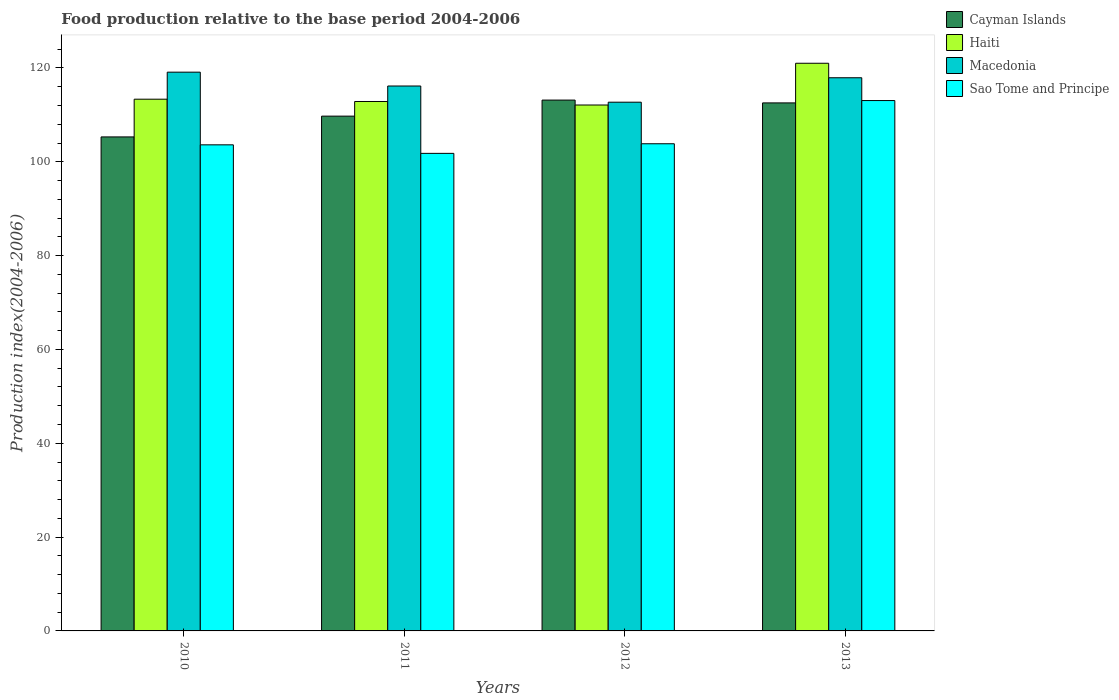How many groups of bars are there?
Make the answer very short. 4. What is the label of the 4th group of bars from the left?
Provide a succinct answer. 2013. In how many cases, is the number of bars for a given year not equal to the number of legend labels?
Give a very brief answer. 0. What is the food production index in Macedonia in 2011?
Offer a terse response. 116.16. Across all years, what is the maximum food production index in Sao Tome and Principe?
Offer a terse response. 113.06. Across all years, what is the minimum food production index in Macedonia?
Give a very brief answer. 112.71. In which year was the food production index in Cayman Islands maximum?
Offer a terse response. 2012. What is the total food production index in Macedonia in the graph?
Offer a terse response. 465.9. What is the difference between the food production index in Haiti in 2010 and that in 2013?
Make the answer very short. -7.66. What is the difference between the food production index in Sao Tome and Principe in 2011 and the food production index in Haiti in 2012?
Offer a terse response. -10.31. What is the average food production index in Haiti per year?
Provide a short and direct response. 114.83. In the year 2011, what is the difference between the food production index in Macedonia and food production index in Cayman Islands?
Provide a succinct answer. 6.42. In how many years, is the food production index in Cayman Islands greater than 92?
Your answer should be compact. 4. What is the ratio of the food production index in Haiti in 2010 to that in 2011?
Keep it short and to the point. 1. Is the food production index in Sao Tome and Principe in 2010 less than that in 2012?
Keep it short and to the point. Yes. What is the difference between the highest and the second highest food production index in Macedonia?
Your answer should be very brief. 1.19. What is the difference between the highest and the lowest food production index in Sao Tome and Principe?
Make the answer very short. 11.26. Is it the case that in every year, the sum of the food production index in Macedonia and food production index in Haiti is greater than the sum of food production index in Sao Tome and Principe and food production index in Cayman Islands?
Make the answer very short. Yes. What does the 1st bar from the left in 2012 represents?
Provide a succinct answer. Cayman Islands. What does the 2nd bar from the right in 2013 represents?
Provide a short and direct response. Macedonia. Is it the case that in every year, the sum of the food production index in Haiti and food production index in Cayman Islands is greater than the food production index in Sao Tome and Principe?
Make the answer very short. Yes. Are all the bars in the graph horizontal?
Your answer should be compact. No. How many years are there in the graph?
Your answer should be compact. 4. What is the difference between two consecutive major ticks on the Y-axis?
Offer a terse response. 20. Does the graph contain any zero values?
Ensure brevity in your answer.  No. Does the graph contain grids?
Offer a very short reply. No. What is the title of the graph?
Ensure brevity in your answer.  Food production relative to the base period 2004-2006. What is the label or title of the Y-axis?
Your answer should be very brief. Production index(2004-2006). What is the Production index(2004-2006) of Cayman Islands in 2010?
Offer a very short reply. 105.31. What is the Production index(2004-2006) of Haiti in 2010?
Provide a succinct answer. 113.35. What is the Production index(2004-2006) of Macedonia in 2010?
Make the answer very short. 119.11. What is the Production index(2004-2006) of Sao Tome and Principe in 2010?
Ensure brevity in your answer.  103.62. What is the Production index(2004-2006) in Cayman Islands in 2011?
Offer a terse response. 109.74. What is the Production index(2004-2006) in Haiti in 2011?
Your answer should be compact. 112.86. What is the Production index(2004-2006) in Macedonia in 2011?
Keep it short and to the point. 116.16. What is the Production index(2004-2006) of Sao Tome and Principe in 2011?
Offer a very short reply. 101.8. What is the Production index(2004-2006) in Cayman Islands in 2012?
Keep it short and to the point. 113.16. What is the Production index(2004-2006) in Haiti in 2012?
Your answer should be very brief. 112.11. What is the Production index(2004-2006) in Macedonia in 2012?
Ensure brevity in your answer.  112.71. What is the Production index(2004-2006) of Sao Tome and Principe in 2012?
Give a very brief answer. 103.85. What is the Production index(2004-2006) of Cayman Islands in 2013?
Provide a short and direct response. 112.56. What is the Production index(2004-2006) of Haiti in 2013?
Keep it short and to the point. 121.01. What is the Production index(2004-2006) in Macedonia in 2013?
Give a very brief answer. 117.92. What is the Production index(2004-2006) of Sao Tome and Principe in 2013?
Ensure brevity in your answer.  113.06. Across all years, what is the maximum Production index(2004-2006) in Cayman Islands?
Offer a very short reply. 113.16. Across all years, what is the maximum Production index(2004-2006) in Haiti?
Your answer should be compact. 121.01. Across all years, what is the maximum Production index(2004-2006) of Macedonia?
Your response must be concise. 119.11. Across all years, what is the maximum Production index(2004-2006) of Sao Tome and Principe?
Your response must be concise. 113.06. Across all years, what is the minimum Production index(2004-2006) in Cayman Islands?
Your answer should be very brief. 105.31. Across all years, what is the minimum Production index(2004-2006) of Haiti?
Give a very brief answer. 112.11. Across all years, what is the minimum Production index(2004-2006) in Macedonia?
Your answer should be very brief. 112.71. Across all years, what is the minimum Production index(2004-2006) of Sao Tome and Principe?
Your answer should be very brief. 101.8. What is the total Production index(2004-2006) in Cayman Islands in the graph?
Keep it short and to the point. 440.77. What is the total Production index(2004-2006) of Haiti in the graph?
Offer a terse response. 459.33. What is the total Production index(2004-2006) of Macedonia in the graph?
Offer a terse response. 465.9. What is the total Production index(2004-2006) in Sao Tome and Principe in the graph?
Offer a terse response. 422.33. What is the difference between the Production index(2004-2006) in Cayman Islands in 2010 and that in 2011?
Give a very brief answer. -4.43. What is the difference between the Production index(2004-2006) of Haiti in 2010 and that in 2011?
Your answer should be very brief. 0.49. What is the difference between the Production index(2004-2006) in Macedonia in 2010 and that in 2011?
Offer a very short reply. 2.95. What is the difference between the Production index(2004-2006) of Sao Tome and Principe in 2010 and that in 2011?
Give a very brief answer. 1.82. What is the difference between the Production index(2004-2006) in Cayman Islands in 2010 and that in 2012?
Offer a terse response. -7.85. What is the difference between the Production index(2004-2006) in Haiti in 2010 and that in 2012?
Make the answer very short. 1.24. What is the difference between the Production index(2004-2006) of Macedonia in 2010 and that in 2012?
Give a very brief answer. 6.4. What is the difference between the Production index(2004-2006) in Sao Tome and Principe in 2010 and that in 2012?
Provide a succinct answer. -0.23. What is the difference between the Production index(2004-2006) in Cayman Islands in 2010 and that in 2013?
Provide a short and direct response. -7.25. What is the difference between the Production index(2004-2006) of Haiti in 2010 and that in 2013?
Ensure brevity in your answer.  -7.66. What is the difference between the Production index(2004-2006) in Macedonia in 2010 and that in 2013?
Make the answer very short. 1.19. What is the difference between the Production index(2004-2006) of Sao Tome and Principe in 2010 and that in 2013?
Offer a terse response. -9.44. What is the difference between the Production index(2004-2006) of Cayman Islands in 2011 and that in 2012?
Offer a terse response. -3.42. What is the difference between the Production index(2004-2006) in Haiti in 2011 and that in 2012?
Provide a short and direct response. 0.75. What is the difference between the Production index(2004-2006) in Macedonia in 2011 and that in 2012?
Your answer should be very brief. 3.45. What is the difference between the Production index(2004-2006) of Sao Tome and Principe in 2011 and that in 2012?
Your response must be concise. -2.05. What is the difference between the Production index(2004-2006) of Cayman Islands in 2011 and that in 2013?
Your answer should be very brief. -2.82. What is the difference between the Production index(2004-2006) of Haiti in 2011 and that in 2013?
Offer a very short reply. -8.15. What is the difference between the Production index(2004-2006) of Macedonia in 2011 and that in 2013?
Your response must be concise. -1.76. What is the difference between the Production index(2004-2006) of Sao Tome and Principe in 2011 and that in 2013?
Make the answer very short. -11.26. What is the difference between the Production index(2004-2006) in Cayman Islands in 2012 and that in 2013?
Your answer should be very brief. 0.6. What is the difference between the Production index(2004-2006) of Macedonia in 2012 and that in 2013?
Keep it short and to the point. -5.21. What is the difference between the Production index(2004-2006) of Sao Tome and Principe in 2012 and that in 2013?
Provide a succinct answer. -9.21. What is the difference between the Production index(2004-2006) in Cayman Islands in 2010 and the Production index(2004-2006) in Haiti in 2011?
Your answer should be very brief. -7.55. What is the difference between the Production index(2004-2006) in Cayman Islands in 2010 and the Production index(2004-2006) in Macedonia in 2011?
Keep it short and to the point. -10.85. What is the difference between the Production index(2004-2006) of Cayman Islands in 2010 and the Production index(2004-2006) of Sao Tome and Principe in 2011?
Provide a short and direct response. 3.51. What is the difference between the Production index(2004-2006) of Haiti in 2010 and the Production index(2004-2006) of Macedonia in 2011?
Keep it short and to the point. -2.81. What is the difference between the Production index(2004-2006) in Haiti in 2010 and the Production index(2004-2006) in Sao Tome and Principe in 2011?
Your answer should be compact. 11.55. What is the difference between the Production index(2004-2006) in Macedonia in 2010 and the Production index(2004-2006) in Sao Tome and Principe in 2011?
Offer a very short reply. 17.31. What is the difference between the Production index(2004-2006) of Cayman Islands in 2010 and the Production index(2004-2006) of Haiti in 2012?
Your response must be concise. -6.8. What is the difference between the Production index(2004-2006) in Cayman Islands in 2010 and the Production index(2004-2006) in Macedonia in 2012?
Offer a terse response. -7.4. What is the difference between the Production index(2004-2006) of Cayman Islands in 2010 and the Production index(2004-2006) of Sao Tome and Principe in 2012?
Make the answer very short. 1.46. What is the difference between the Production index(2004-2006) in Haiti in 2010 and the Production index(2004-2006) in Macedonia in 2012?
Give a very brief answer. 0.64. What is the difference between the Production index(2004-2006) of Macedonia in 2010 and the Production index(2004-2006) of Sao Tome and Principe in 2012?
Ensure brevity in your answer.  15.26. What is the difference between the Production index(2004-2006) in Cayman Islands in 2010 and the Production index(2004-2006) in Haiti in 2013?
Keep it short and to the point. -15.7. What is the difference between the Production index(2004-2006) of Cayman Islands in 2010 and the Production index(2004-2006) of Macedonia in 2013?
Provide a succinct answer. -12.61. What is the difference between the Production index(2004-2006) of Cayman Islands in 2010 and the Production index(2004-2006) of Sao Tome and Principe in 2013?
Provide a succinct answer. -7.75. What is the difference between the Production index(2004-2006) in Haiti in 2010 and the Production index(2004-2006) in Macedonia in 2013?
Your response must be concise. -4.57. What is the difference between the Production index(2004-2006) in Haiti in 2010 and the Production index(2004-2006) in Sao Tome and Principe in 2013?
Offer a terse response. 0.29. What is the difference between the Production index(2004-2006) in Macedonia in 2010 and the Production index(2004-2006) in Sao Tome and Principe in 2013?
Your answer should be very brief. 6.05. What is the difference between the Production index(2004-2006) of Cayman Islands in 2011 and the Production index(2004-2006) of Haiti in 2012?
Your response must be concise. -2.37. What is the difference between the Production index(2004-2006) of Cayman Islands in 2011 and the Production index(2004-2006) of Macedonia in 2012?
Provide a succinct answer. -2.97. What is the difference between the Production index(2004-2006) of Cayman Islands in 2011 and the Production index(2004-2006) of Sao Tome and Principe in 2012?
Offer a terse response. 5.89. What is the difference between the Production index(2004-2006) of Haiti in 2011 and the Production index(2004-2006) of Macedonia in 2012?
Your response must be concise. 0.15. What is the difference between the Production index(2004-2006) of Haiti in 2011 and the Production index(2004-2006) of Sao Tome and Principe in 2012?
Keep it short and to the point. 9.01. What is the difference between the Production index(2004-2006) in Macedonia in 2011 and the Production index(2004-2006) in Sao Tome and Principe in 2012?
Keep it short and to the point. 12.31. What is the difference between the Production index(2004-2006) of Cayman Islands in 2011 and the Production index(2004-2006) of Haiti in 2013?
Your answer should be very brief. -11.27. What is the difference between the Production index(2004-2006) of Cayman Islands in 2011 and the Production index(2004-2006) of Macedonia in 2013?
Provide a succinct answer. -8.18. What is the difference between the Production index(2004-2006) of Cayman Islands in 2011 and the Production index(2004-2006) of Sao Tome and Principe in 2013?
Provide a short and direct response. -3.32. What is the difference between the Production index(2004-2006) of Haiti in 2011 and the Production index(2004-2006) of Macedonia in 2013?
Your response must be concise. -5.06. What is the difference between the Production index(2004-2006) of Haiti in 2011 and the Production index(2004-2006) of Sao Tome and Principe in 2013?
Give a very brief answer. -0.2. What is the difference between the Production index(2004-2006) of Cayman Islands in 2012 and the Production index(2004-2006) of Haiti in 2013?
Provide a succinct answer. -7.85. What is the difference between the Production index(2004-2006) of Cayman Islands in 2012 and the Production index(2004-2006) of Macedonia in 2013?
Your answer should be compact. -4.76. What is the difference between the Production index(2004-2006) in Cayman Islands in 2012 and the Production index(2004-2006) in Sao Tome and Principe in 2013?
Provide a succinct answer. 0.1. What is the difference between the Production index(2004-2006) of Haiti in 2012 and the Production index(2004-2006) of Macedonia in 2013?
Provide a succinct answer. -5.81. What is the difference between the Production index(2004-2006) of Haiti in 2012 and the Production index(2004-2006) of Sao Tome and Principe in 2013?
Make the answer very short. -0.95. What is the difference between the Production index(2004-2006) in Macedonia in 2012 and the Production index(2004-2006) in Sao Tome and Principe in 2013?
Make the answer very short. -0.35. What is the average Production index(2004-2006) in Cayman Islands per year?
Your response must be concise. 110.19. What is the average Production index(2004-2006) of Haiti per year?
Make the answer very short. 114.83. What is the average Production index(2004-2006) of Macedonia per year?
Your answer should be very brief. 116.47. What is the average Production index(2004-2006) of Sao Tome and Principe per year?
Offer a very short reply. 105.58. In the year 2010, what is the difference between the Production index(2004-2006) in Cayman Islands and Production index(2004-2006) in Haiti?
Offer a terse response. -8.04. In the year 2010, what is the difference between the Production index(2004-2006) in Cayman Islands and Production index(2004-2006) in Macedonia?
Your answer should be compact. -13.8. In the year 2010, what is the difference between the Production index(2004-2006) in Cayman Islands and Production index(2004-2006) in Sao Tome and Principe?
Ensure brevity in your answer.  1.69. In the year 2010, what is the difference between the Production index(2004-2006) of Haiti and Production index(2004-2006) of Macedonia?
Your answer should be very brief. -5.76. In the year 2010, what is the difference between the Production index(2004-2006) in Haiti and Production index(2004-2006) in Sao Tome and Principe?
Provide a succinct answer. 9.73. In the year 2010, what is the difference between the Production index(2004-2006) in Macedonia and Production index(2004-2006) in Sao Tome and Principe?
Give a very brief answer. 15.49. In the year 2011, what is the difference between the Production index(2004-2006) of Cayman Islands and Production index(2004-2006) of Haiti?
Provide a succinct answer. -3.12. In the year 2011, what is the difference between the Production index(2004-2006) of Cayman Islands and Production index(2004-2006) of Macedonia?
Your answer should be very brief. -6.42. In the year 2011, what is the difference between the Production index(2004-2006) in Cayman Islands and Production index(2004-2006) in Sao Tome and Principe?
Make the answer very short. 7.94. In the year 2011, what is the difference between the Production index(2004-2006) of Haiti and Production index(2004-2006) of Sao Tome and Principe?
Your answer should be compact. 11.06. In the year 2011, what is the difference between the Production index(2004-2006) in Macedonia and Production index(2004-2006) in Sao Tome and Principe?
Offer a terse response. 14.36. In the year 2012, what is the difference between the Production index(2004-2006) in Cayman Islands and Production index(2004-2006) in Haiti?
Your response must be concise. 1.05. In the year 2012, what is the difference between the Production index(2004-2006) of Cayman Islands and Production index(2004-2006) of Macedonia?
Ensure brevity in your answer.  0.45. In the year 2012, what is the difference between the Production index(2004-2006) in Cayman Islands and Production index(2004-2006) in Sao Tome and Principe?
Ensure brevity in your answer.  9.31. In the year 2012, what is the difference between the Production index(2004-2006) in Haiti and Production index(2004-2006) in Sao Tome and Principe?
Offer a very short reply. 8.26. In the year 2012, what is the difference between the Production index(2004-2006) of Macedonia and Production index(2004-2006) of Sao Tome and Principe?
Provide a succinct answer. 8.86. In the year 2013, what is the difference between the Production index(2004-2006) in Cayman Islands and Production index(2004-2006) in Haiti?
Offer a very short reply. -8.45. In the year 2013, what is the difference between the Production index(2004-2006) in Cayman Islands and Production index(2004-2006) in Macedonia?
Provide a succinct answer. -5.36. In the year 2013, what is the difference between the Production index(2004-2006) in Haiti and Production index(2004-2006) in Macedonia?
Provide a succinct answer. 3.09. In the year 2013, what is the difference between the Production index(2004-2006) in Haiti and Production index(2004-2006) in Sao Tome and Principe?
Provide a short and direct response. 7.95. In the year 2013, what is the difference between the Production index(2004-2006) in Macedonia and Production index(2004-2006) in Sao Tome and Principe?
Your answer should be very brief. 4.86. What is the ratio of the Production index(2004-2006) in Cayman Islands in 2010 to that in 2011?
Your response must be concise. 0.96. What is the ratio of the Production index(2004-2006) of Haiti in 2010 to that in 2011?
Keep it short and to the point. 1. What is the ratio of the Production index(2004-2006) in Macedonia in 2010 to that in 2011?
Your response must be concise. 1.03. What is the ratio of the Production index(2004-2006) of Sao Tome and Principe in 2010 to that in 2011?
Provide a short and direct response. 1.02. What is the ratio of the Production index(2004-2006) of Cayman Islands in 2010 to that in 2012?
Your answer should be compact. 0.93. What is the ratio of the Production index(2004-2006) of Haiti in 2010 to that in 2012?
Offer a very short reply. 1.01. What is the ratio of the Production index(2004-2006) in Macedonia in 2010 to that in 2012?
Offer a terse response. 1.06. What is the ratio of the Production index(2004-2006) in Sao Tome and Principe in 2010 to that in 2012?
Provide a succinct answer. 1. What is the ratio of the Production index(2004-2006) of Cayman Islands in 2010 to that in 2013?
Your answer should be compact. 0.94. What is the ratio of the Production index(2004-2006) of Haiti in 2010 to that in 2013?
Ensure brevity in your answer.  0.94. What is the ratio of the Production index(2004-2006) of Sao Tome and Principe in 2010 to that in 2013?
Provide a short and direct response. 0.92. What is the ratio of the Production index(2004-2006) of Cayman Islands in 2011 to that in 2012?
Provide a short and direct response. 0.97. What is the ratio of the Production index(2004-2006) in Macedonia in 2011 to that in 2012?
Provide a short and direct response. 1.03. What is the ratio of the Production index(2004-2006) in Sao Tome and Principe in 2011 to that in 2012?
Offer a terse response. 0.98. What is the ratio of the Production index(2004-2006) of Cayman Islands in 2011 to that in 2013?
Keep it short and to the point. 0.97. What is the ratio of the Production index(2004-2006) of Haiti in 2011 to that in 2013?
Ensure brevity in your answer.  0.93. What is the ratio of the Production index(2004-2006) in Macedonia in 2011 to that in 2013?
Your response must be concise. 0.99. What is the ratio of the Production index(2004-2006) of Sao Tome and Principe in 2011 to that in 2013?
Your answer should be very brief. 0.9. What is the ratio of the Production index(2004-2006) in Haiti in 2012 to that in 2013?
Your response must be concise. 0.93. What is the ratio of the Production index(2004-2006) of Macedonia in 2012 to that in 2013?
Offer a very short reply. 0.96. What is the ratio of the Production index(2004-2006) in Sao Tome and Principe in 2012 to that in 2013?
Provide a short and direct response. 0.92. What is the difference between the highest and the second highest Production index(2004-2006) of Haiti?
Make the answer very short. 7.66. What is the difference between the highest and the second highest Production index(2004-2006) in Macedonia?
Provide a succinct answer. 1.19. What is the difference between the highest and the second highest Production index(2004-2006) of Sao Tome and Principe?
Give a very brief answer. 9.21. What is the difference between the highest and the lowest Production index(2004-2006) of Cayman Islands?
Keep it short and to the point. 7.85. What is the difference between the highest and the lowest Production index(2004-2006) in Haiti?
Provide a succinct answer. 8.9. What is the difference between the highest and the lowest Production index(2004-2006) of Sao Tome and Principe?
Provide a succinct answer. 11.26. 